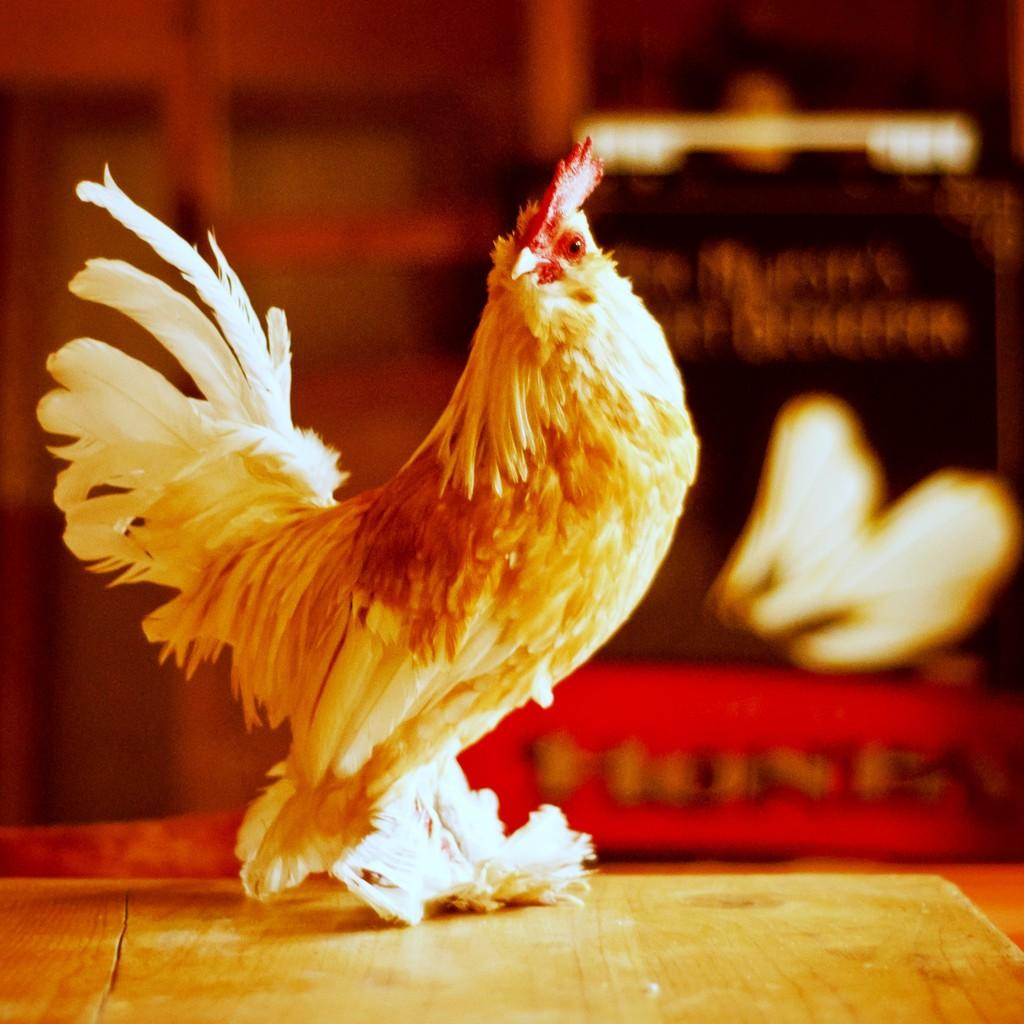What is the main subject of the image? The main subject of the image is a cock sculpture. What are the notable features of the cock sculpture? The cock sculpture has feathers. On what is the cock sculpture placed? The cock sculpture is placed on a wooden plank. Can you describe the objects behind the cock sculpture? The visibility of the objects behind the cock sculpture is unclear, so it is difficult to describe them. What type of juice is being served in the image? There is no juice present in the image; it features a cock sculpture placed on a wooden plank. What day of the week is depicted in the image? The image does not depict a specific day of the week; it only shows a cock sculpture and a wooden plank. 